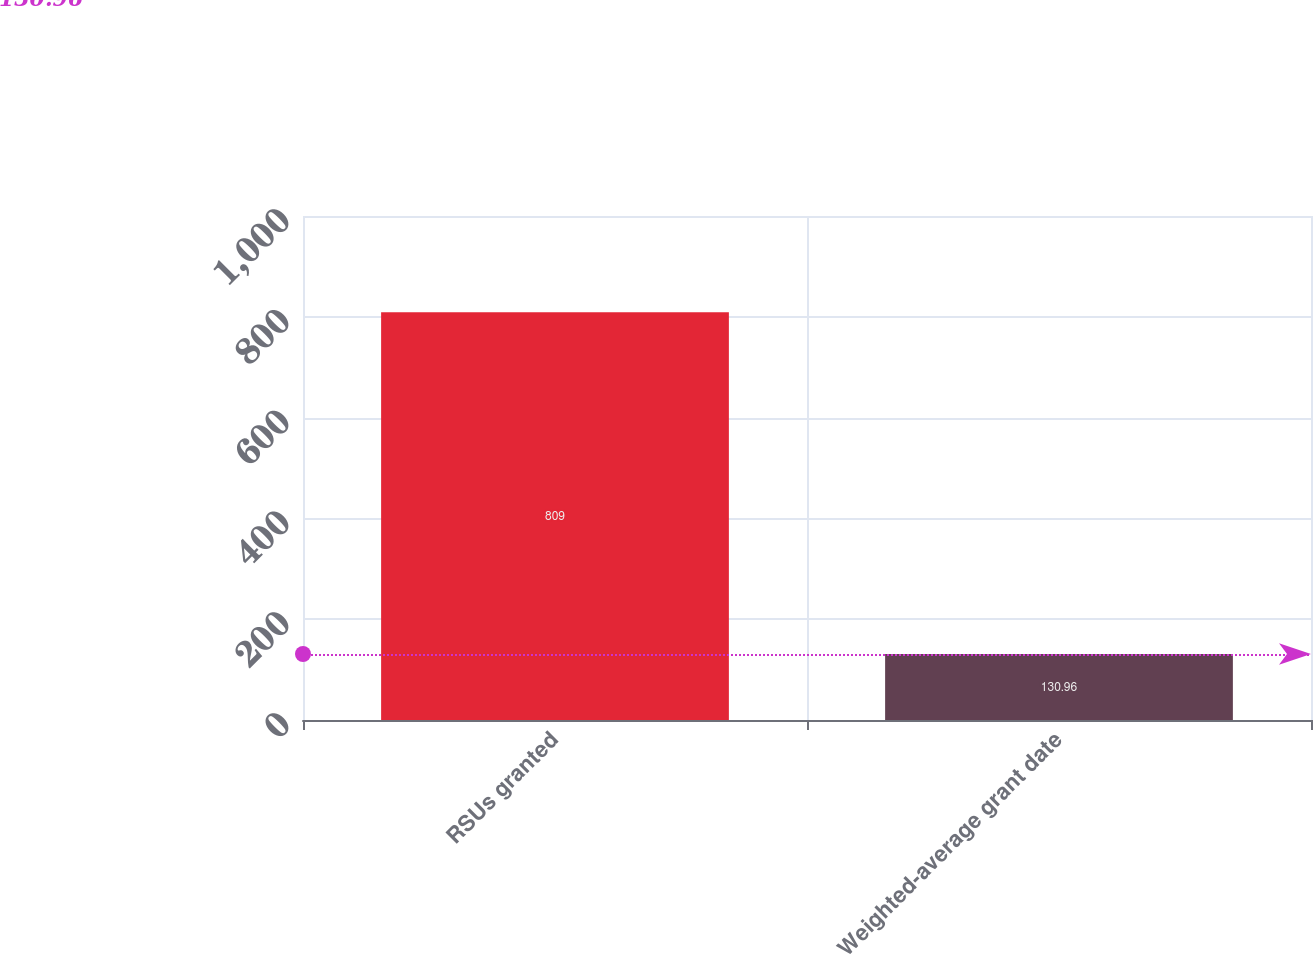<chart> <loc_0><loc_0><loc_500><loc_500><bar_chart><fcel>RSUs granted<fcel>Weighted-average grant date<nl><fcel>809<fcel>130.96<nl></chart> 